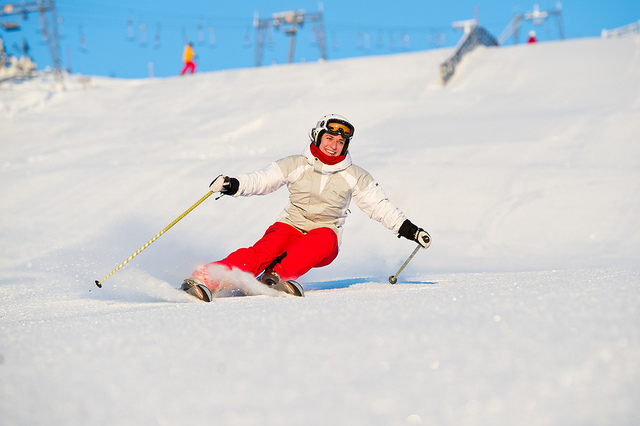At what time of the year is this picture likely to have been taken? Given the ample snow coverage and the clear skies, it appears this photo was taken during the winter season when skiing resorts are typically open and active. 